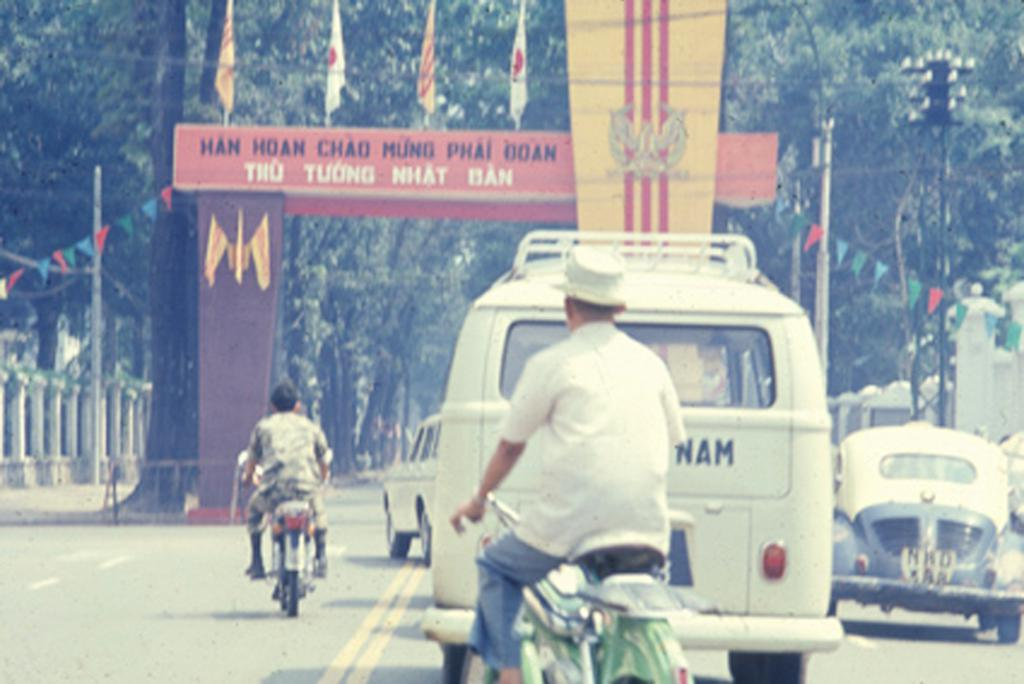What can be seen on the road in the image? There are vehicles on the road in the image. Can you describe the motorcycle in the image? There are two persons on a motorcycle in the image. What is visible in the background of the image? There are trees, poles, and flags in the background of the image. What is the reaction of the trees to the plot in the image? There is no plot or reaction of the trees in the image; it simply shows vehicles on the road, a motorcycle with two persons, and trees, poles, and flags in the background. 